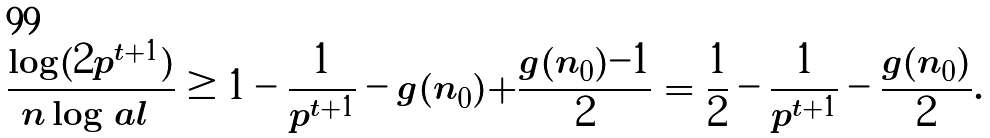<formula> <loc_0><loc_0><loc_500><loc_500>\frac { \log ( 2 p ^ { t + 1 } ) } { n \log | \ a l | } & \geq 1 - \frac { 1 } { p ^ { t + 1 } } - g ( n _ { 0 } ) + \frac { g ( n _ { 0 } ) - 1 } { 2 } = \frac { 1 } { 2 } - \frac { 1 } { p ^ { t + 1 } } - \frac { g ( n _ { 0 } ) } { 2 } .</formula> 